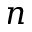Convert formula to latex. <formula><loc_0><loc_0><loc_500><loc_500>n</formula> 